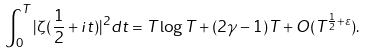Convert formula to latex. <formula><loc_0><loc_0><loc_500><loc_500>\int _ { 0 } ^ { T } | \zeta ( \frac { 1 } { 2 } + i t ) | ^ { 2 } d t = T \log T + ( 2 \gamma - 1 ) T + O ( T ^ { \frac { 1 } { 2 } + \varepsilon } ) .</formula> 